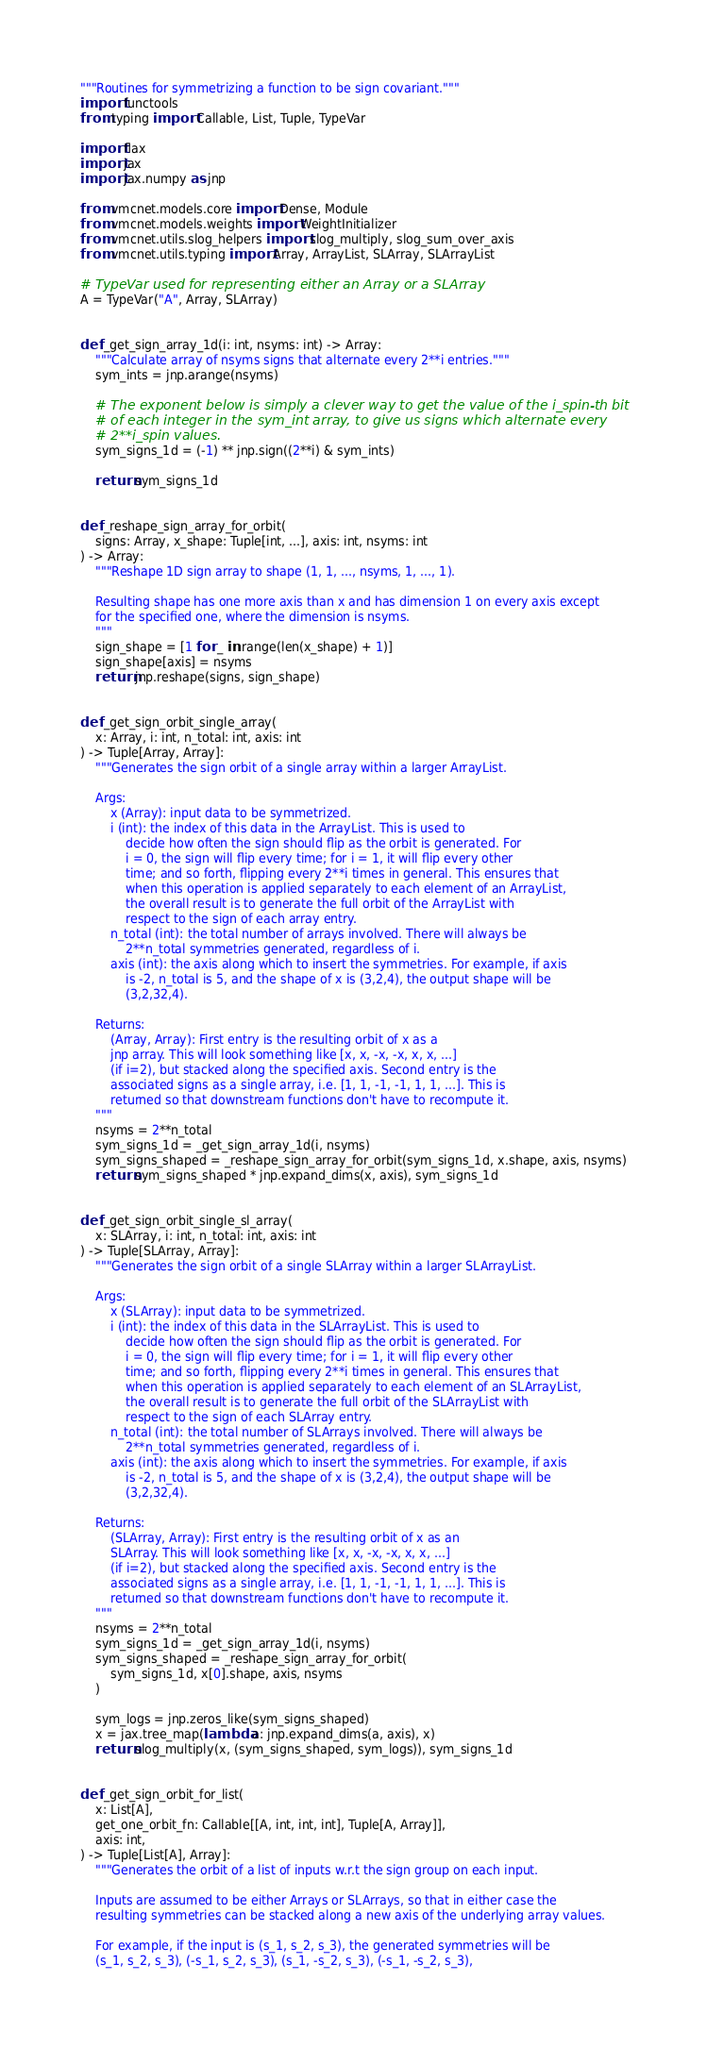Convert code to text. <code><loc_0><loc_0><loc_500><loc_500><_Python_>"""Routines for symmetrizing a function to be sign covariant."""
import functools
from typing import Callable, List, Tuple, TypeVar

import flax
import jax
import jax.numpy as jnp

from vmcnet.models.core import Dense, Module
from vmcnet.models.weights import WeightInitializer
from vmcnet.utils.slog_helpers import slog_multiply, slog_sum_over_axis
from vmcnet.utils.typing import Array, ArrayList, SLArray, SLArrayList

# TypeVar used for representing either an Array or a SLArray
A = TypeVar("A", Array, SLArray)


def _get_sign_array_1d(i: int, nsyms: int) -> Array:
    """Calculate array of nsyms signs that alternate every 2**i entries."""
    sym_ints = jnp.arange(nsyms)

    # The exponent below is simply a clever way to get the value of the i_spin-th bit
    # of each integer in the sym_int array, to give us signs which alternate every
    # 2**i_spin values.
    sym_signs_1d = (-1) ** jnp.sign((2**i) & sym_ints)

    return sym_signs_1d


def _reshape_sign_array_for_orbit(
    signs: Array, x_shape: Tuple[int, ...], axis: int, nsyms: int
) -> Array:
    """Reshape 1D sign array to shape (1, 1, ..., nsyms, 1, ..., 1).

    Resulting shape has one more axis than x and has dimension 1 on every axis except
    for the specified one, where the dimension is nsyms.
    """
    sign_shape = [1 for _ in range(len(x_shape) + 1)]
    sign_shape[axis] = nsyms
    return jnp.reshape(signs, sign_shape)


def _get_sign_orbit_single_array(
    x: Array, i: int, n_total: int, axis: int
) -> Tuple[Array, Array]:
    """Generates the sign orbit of a single array within a larger ArrayList.

    Args:
        x (Array): input data to be symmetrized.
        i (int): the index of this data in the ArrayList. This is used to
            decide how often the sign should flip as the orbit is generated. For
            i = 0, the sign will flip every time; for i = 1, it will flip every other
            time; and so forth, flipping every 2**i times in general. This ensures that
            when this operation is applied separately to each element of an ArrayList,
            the overall result is to generate the full orbit of the ArrayList with
            respect to the sign of each array entry.
        n_total (int): the total number of arrays involved. There will always be
            2**n_total symmetries generated, regardless of i.
        axis (int): the axis along which to insert the symmetries. For example, if axis
            is -2, n_total is 5, and the shape of x is (3,2,4), the output shape will be
            (3,2,32,4).

    Returns:
        (Array, Array): First entry is the resulting orbit of x as a
        jnp array. This will look something like [x, x, -x, -x, x, x, ...]
        (if i=2), but stacked along the specified axis. Second entry is the
        associated signs as a single array, i.e. [1, 1, -1, -1, 1, 1, ...]. This is
        returned so that downstream functions don't have to recompute it.
    """
    nsyms = 2**n_total
    sym_signs_1d = _get_sign_array_1d(i, nsyms)
    sym_signs_shaped = _reshape_sign_array_for_orbit(sym_signs_1d, x.shape, axis, nsyms)
    return sym_signs_shaped * jnp.expand_dims(x, axis), sym_signs_1d


def _get_sign_orbit_single_sl_array(
    x: SLArray, i: int, n_total: int, axis: int
) -> Tuple[SLArray, Array]:
    """Generates the sign orbit of a single SLArray within a larger SLArrayList.

    Args:
        x (SLArray): input data to be symmetrized.
        i (int): the index of this data in the SLArrayList. This is used to
            decide how often the sign should flip as the orbit is generated. For
            i = 0, the sign will flip every time; for i = 1, it will flip every other
            time; and so forth, flipping every 2**i times in general. This ensures that
            when this operation is applied separately to each element of an SLArrayList,
            the overall result is to generate the full orbit of the SLArrayList with
            respect to the sign of each SLArray entry.
        n_total (int): the total number of SLArrays involved. There will always be
            2**n_total symmetries generated, regardless of i.
        axis (int): the axis along which to insert the symmetries. For example, if axis
            is -2, n_total is 5, and the shape of x is (3,2,4), the output shape will be
            (3,2,32,4).

    Returns:
        (SLArray, Array): First entry is the resulting orbit of x as an
        SLArray. This will look something like [x, x, -x, -x, x, x, ...]
        (if i=2), but stacked along the specified axis. Second entry is the
        associated signs as a single array, i.e. [1, 1, -1, -1, 1, 1, ...]. This is
        returned so that downstream functions don't have to recompute it.
    """
    nsyms = 2**n_total
    sym_signs_1d = _get_sign_array_1d(i, nsyms)
    sym_signs_shaped = _reshape_sign_array_for_orbit(
        sym_signs_1d, x[0].shape, axis, nsyms
    )

    sym_logs = jnp.zeros_like(sym_signs_shaped)
    x = jax.tree_map(lambda a: jnp.expand_dims(a, axis), x)
    return slog_multiply(x, (sym_signs_shaped, sym_logs)), sym_signs_1d


def _get_sign_orbit_for_list(
    x: List[A],
    get_one_orbit_fn: Callable[[A, int, int, int], Tuple[A, Array]],
    axis: int,
) -> Tuple[List[A], Array]:
    """Generates the orbit of a list of inputs w.r.t the sign group on each input.

    Inputs are assumed to be either Arrays or SLArrays, so that in either case the
    resulting symmetries can be stacked along a new axis of the underlying array values.

    For example, if the input is (s_1, s_2, s_3), the generated symmetries will be
    (s_1, s_2, s_3), (-s_1, s_2, s_3), (s_1, -s_2, s_3), (-s_1, -s_2, s_3),</code> 